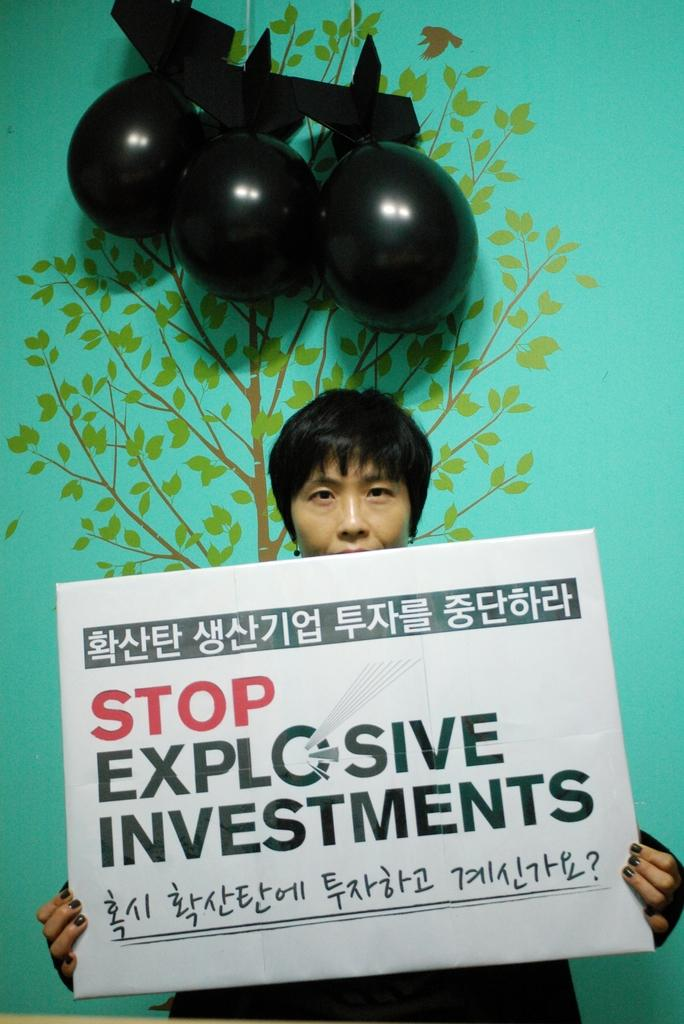What is the main subject in the foreground of the picture? There is a person in the foreground of the picture. What is the person holding in the picture? The person is holding a placard. What can be read on the placard? There is text on the placard. What can be seen in the background of the picture? There are balloons and a wall in the background of the picture. What design is on the wall? There is a design of a tree on the wall. How far away is the plough from the person in the image? There is no plough present in the image. What hour is it in the image? The image does not provide any information about the time of day or hour. 